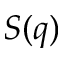Convert formula to latex. <formula><loc_0><loc_0><loc_500><loc_500>S ( q )</formula> 